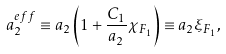Convert formula to latex. <formula><loc_0><loc_0><loc_500><loc_500>a ^ { e f f } _ { 2 } \equiv a _ { 2 } \left ( 1 + \frac { C _ { 1 } } { a _ { 2 } } \chi _ { F _ { 1 } } \right ) \equiv a _ { 2 } \xi _ { F _ { 1 } } ,</formula> 